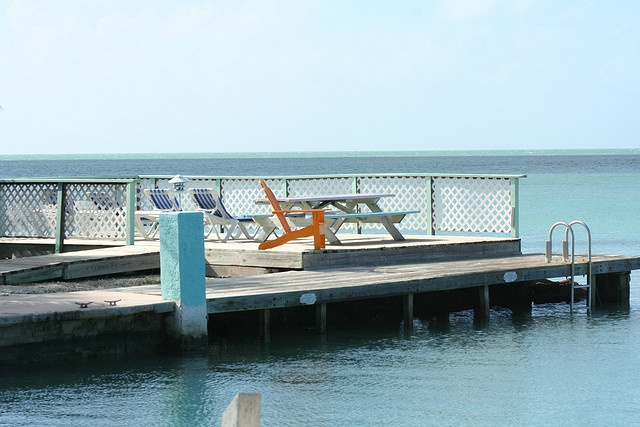Describe the objects in this image and their specific colors. I can see chair in white, darkgray, lightgray, lightblue, and gray tones, chair in white, brown, darkgray, and lightgray tones, dining table in white, gray, darkgray, lightgray, and black tones, bench in white, gray, darkgray, and lightgray tones, and chair in white, darkgray, lightgray, gray, and blue tones in this image. 